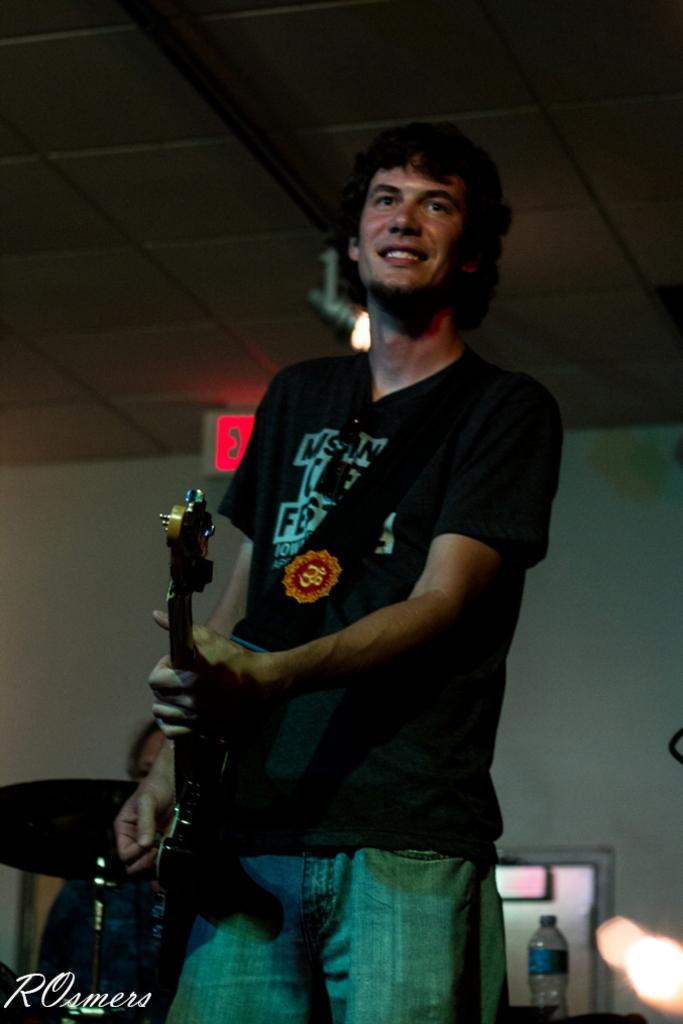Who is the main subject in the image? There is a person in the image. What is the person wearing? The person is wearing a black color T-shirt. What activity is the person engaged in? The person is playing a guitar. Can you tell me how many teeth the person has in the image? There is no information about the person's teeth in the image, so it cannot be determined. 